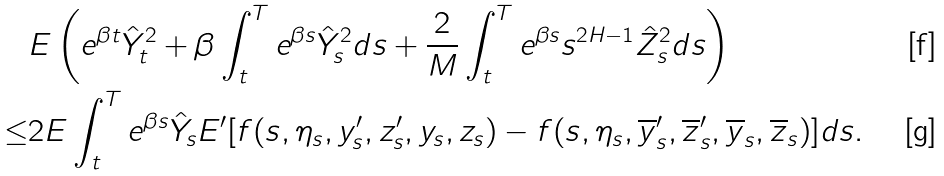Convert formula to latex. <formula><loc_0><loc_0><loc_500><loc_500>& E \left ( e ^ { \beta t } \hat { Y } _ { t } ^ { 2 } + \beta \int _ { t } ^ { T } e ^ { \beta s } \hat { Y } _ { s } ^ { 2 } d s + \frac { 2 } { M } \int _ { t } ^ { T } e ^ { \beta s } s ^ { 2 H - 1 } \hat { Z } _ { s } ^ { 2 } d s \right ) \\ \leq & 2 E \int _ { t } ^ { T } e ^ { \beta s } \hat { Y } _ { s } E ^ { \prime } [ f ( s , \eta _ { s } , y ^ { \prime } _ { s } , z ^ { \prime } _ { s } , y _ { s } , z _ { s } ) - f ( s , \eta _ { s } , \overline { y } ^ { \prime } _ { s } , \overline { z } ^ { \prime } _ { s } , \overline { y } _ { s } , \overline { z } _ { s } ) ] d s .</formula> 